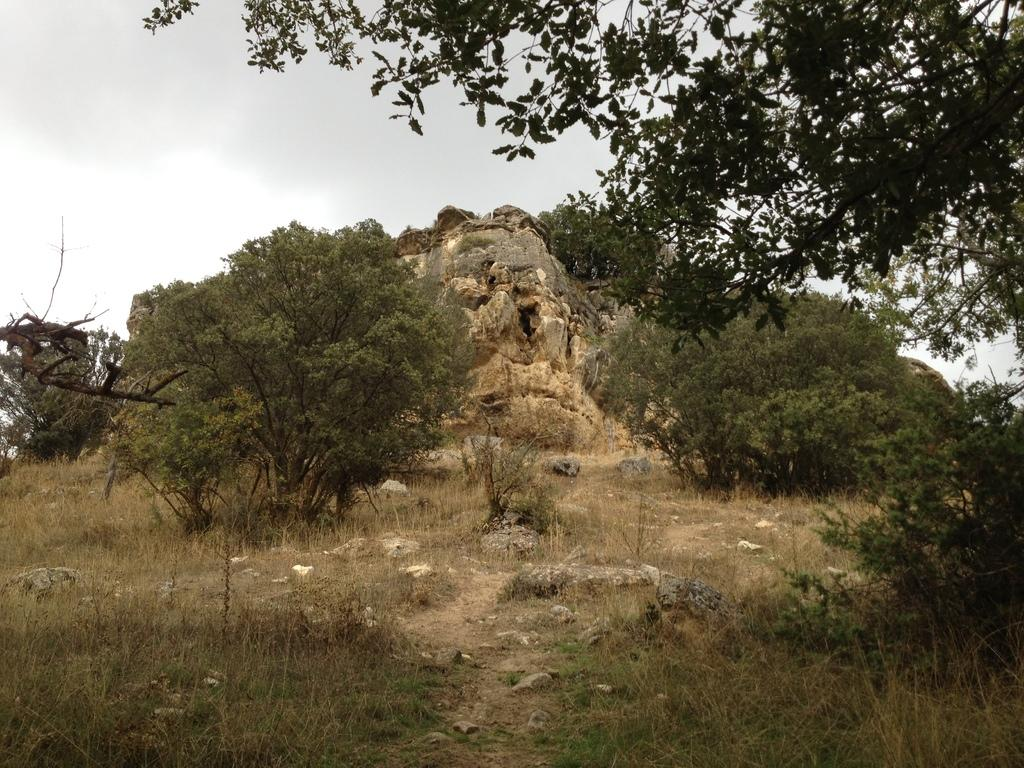What type of vegetation can be seen in the image? There is grass and trees in the image. What other natural elements are present in the image? There are rocks in the image. What can be seen in the background of the image? The sky is visible in the background of the image. Can you hear the whistle of the birds in the image? There are no birds or whistling sounds mentioned in the image, so it cannot be determined if birds are present or if they are whistling. 